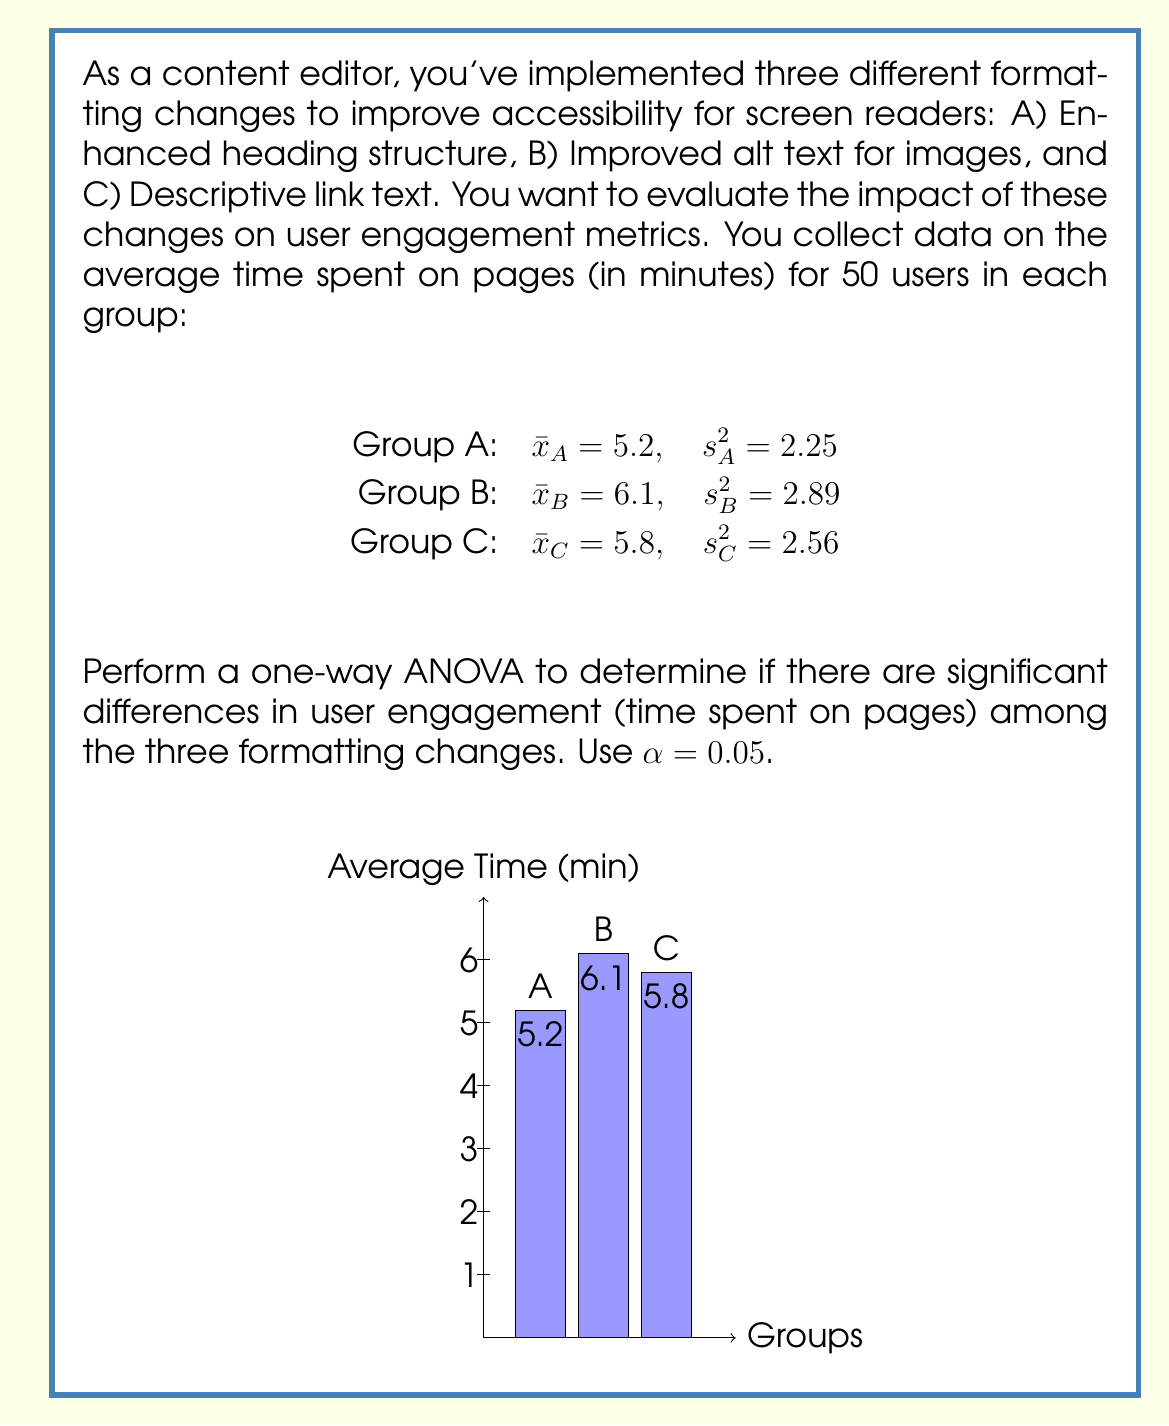Help me with this question. To perform a one-way ANOVA, we need to follow these steps:

1) Calculate the sum of squares between groups (SSB):
   $$SSB = n\sum_{i=1}^k (\bar{x}_i - \bar{x})^2$$
   where $n$ is the number of observations per group, $k$ is the number of groups, $\bar{x}_i$ is the mean of each group, and $\bar{x}$ is the grand mean.

2) Calculate the sum of squares within groups (SSW):
   $$SSW = (n-1)\sum_{i=1}^k s_i^2$$
   where $s_i^2$ is the variance of each group.

3) Calculate the degrees of freedom:
   $df_{between} = k - 1 = 3 - 1 = 2$
   $df_{within} = k(n-1) = 3(50-1) = 147$

4) Calculate the mean squares:
   $$MSB = \frac{SSB}{df_{between}}$$
   $$MSW = \frac{SSW}{df_{within}}$$

5) Calculate the F-statistic:
   $$F = \frac{MSB}{MSW}$$

6) Compare the F-statistic to the critical F-value at $\alpha = 0.05$.

Let's perform the calculations:

1) Grand mean: $\bar{x} = \frac{5.2 + 6.1 + 5.8}{3} = 5.7$

   $SSB = 50[(5.2 - 5.7)^2 + (6.1 - 5.7)^2 + (5.8 - 5.7)^2]$
        $= 50[0.25 + 0.16 + 0.01] = 21$

2) $SSW = 49(2.25 + 2.89 + 2.56) = 377.3$

3) Degrees of freedom: $df_{between} = 2$, $df_{within} = 147$

4) Mean squares:
   $MSB = \frac{21}{2} = 10.5$
   $MSW = \frac{377.3}{147} = 2.567$

5) F-statistic:
   $F = \frac{10.5}{2.567} = 4.09$

6) The critical F-value for $F(2,147)$ at $\alpha = 0.05$ is approximately 3.06.

Since our calculated F-statistic (4.09) is greater than the critical F-value (3.06), we reject the null hypothesis.
Answer: $F(2,147) = 4.09$, $p < 0.05$. There are significant differences in user engagement among the three formatting changes. 